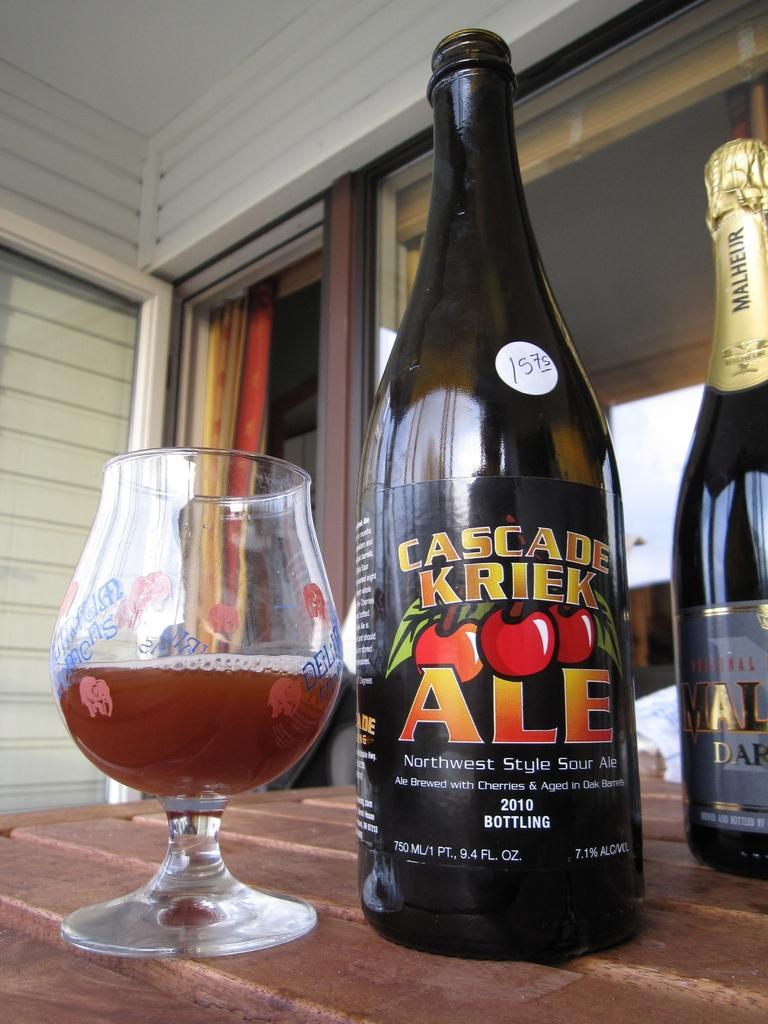<image>
Write a terse but informative summary of the picture. A bottle of Cascade Kriek Ale is on a table standing next to a half full glass of drink and a bottle whose label is too dificult to make out. 